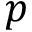Convert formula to latex. <formula><loc_0><loc_0><loc_500><loc_500>p</formula> 